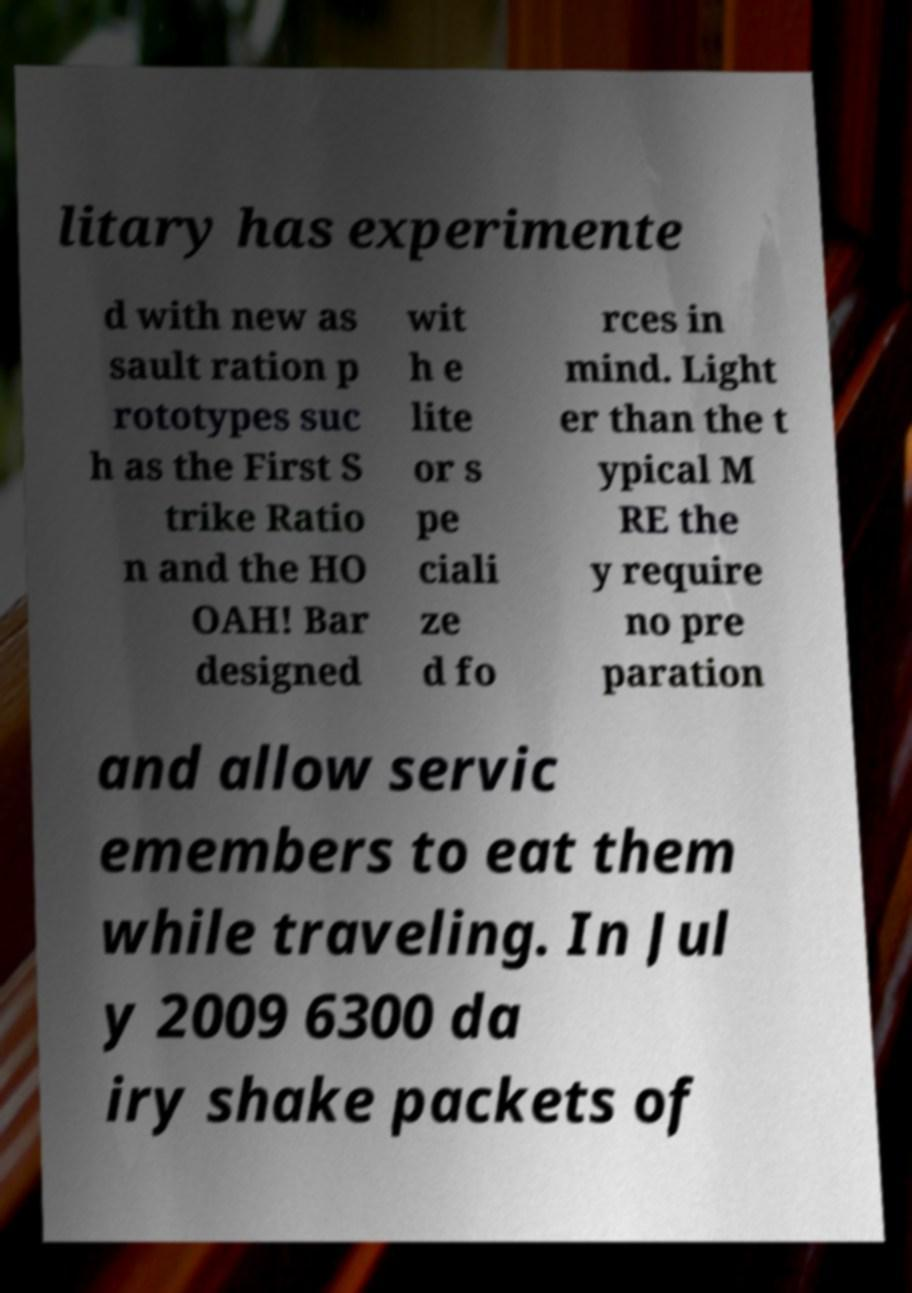Please read and relay the text visible in this image. What does it say? litary has experimente d with new as sault ration p rototypes suc h as the First S trike Ratio n and the HO OAH! Bar designed wit h e lite or s pe ciali ze d fo rces in mind. Light er than the t ypical M RE the y require no pre paration and allow servic emembers to eat them while traveling. In Jul y 2009 6300 da iry shake packets of 